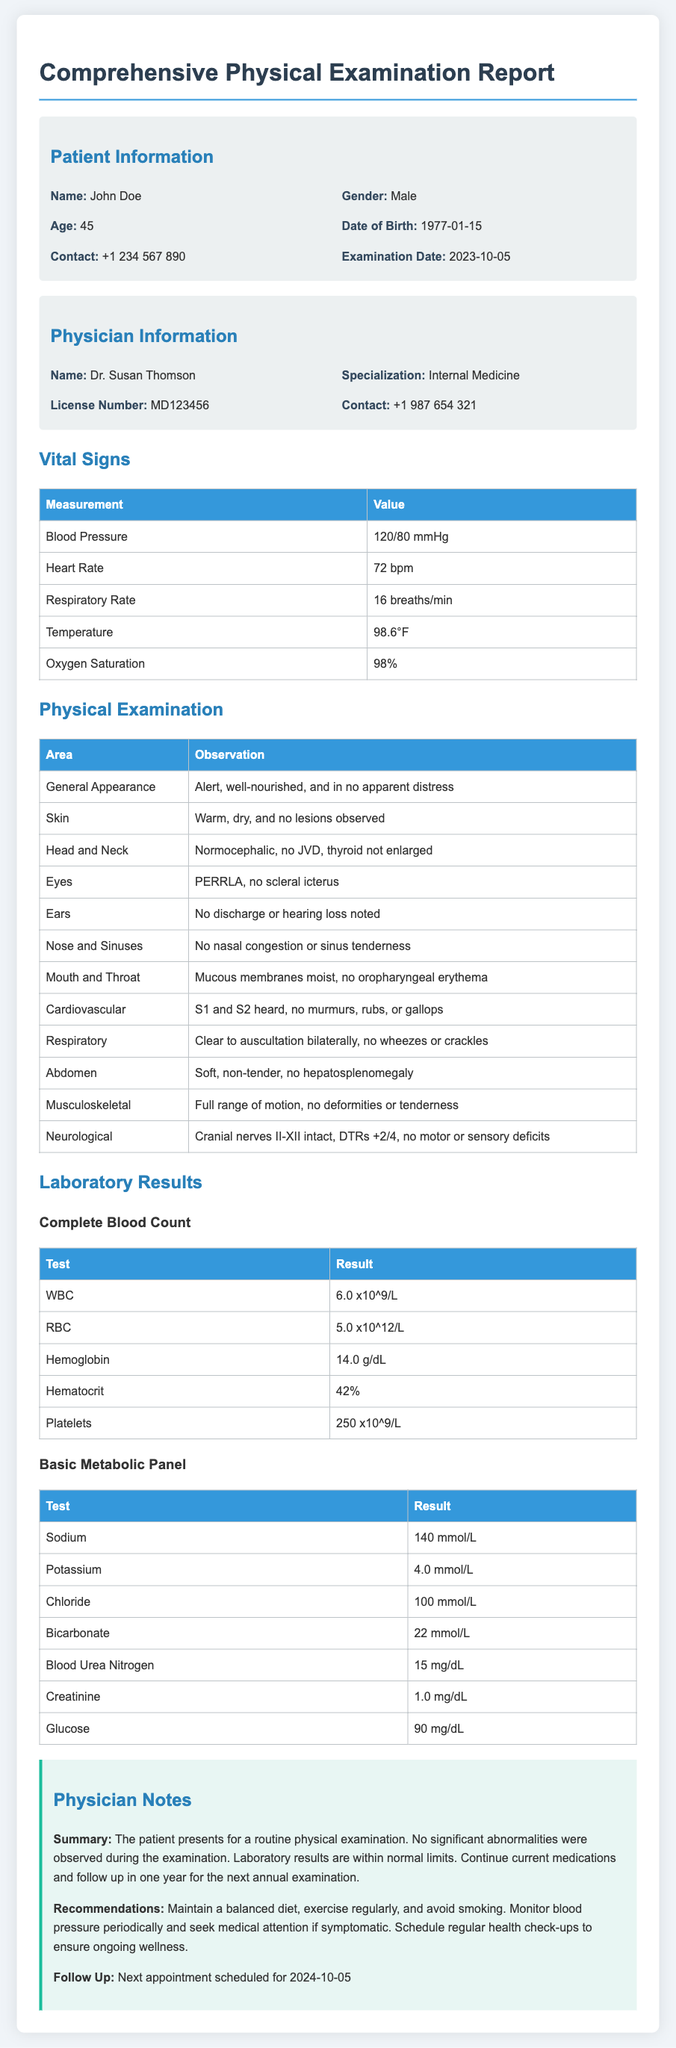What is the patient's name? The patient's name is stated in the Patient Information section of the document.
Answer: John Doe What is the examination date? The date of examination is mentioned in the Patient Information section.
Answer: 2023-10-05 What is Dr. Susan Thomson's specialization? The physician's specialization is listed under the Physician Information section.
Answer: Internal Medicine What was the patient's blood pressure measurement? This vital sign is provided in the Vital Signs section of the document.
Answer: 120/80 mmHg How many years old is the patient? The patient's age is indicated in the Patient Information section based on the given date of birth.
Answer: 45 What were the results for WBC in the Complete Blood Count? The specific test result can be found in the Laboratory Results section.
Answer: 6.0 x10^9/L What is the recommendation regarding exercise? Recommendations from the Physician Notes will include suggestions for lifestyle maintenance.
Answer: Exercise regularly What is the follow-up appointment date? The date for the next appointment is given in the Physician Notes section.
Answer: 2024-10-05 What was observed in the Cardiovascular examination? Observation details are provided in the Physical Examination section related to the cardiovascular health.
Answer: S1 and S2 heard, no murmurs, rubs, or gallops 